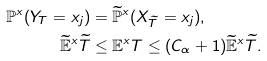Convert formula to latex. <formula><loc_0><loc_0><loc_500><loc_500>\mathbb { P } ^ { x } ( Y _ { T } = x _ { j } ) & = \widetilde { \mathbb { P } } ^ { x } ( X _ { \widetilde { T } } = x _ { j } ) , \\ \widetilde { \mathbb { E } } ^ { x } \widetilde { T } & \leq \mathbb { E } ^ { x } T \leq ( C _ { \alpha } + 1 ) \widetilde { \mathbb { E } } ^ { x } \widetilde { T } .</formula> 